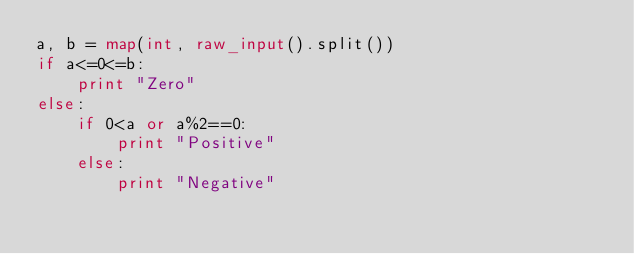Convert code to text. <code><loc_0><loc_0><loc_500><loc_500><_Python_>a, b = map(int, raw_input().split())
if a<=0<=b:
    print "Zero"
else:
    if 0<a or a%2==0:
        print "Positive"
    else:
        print "Negative"
</code> 